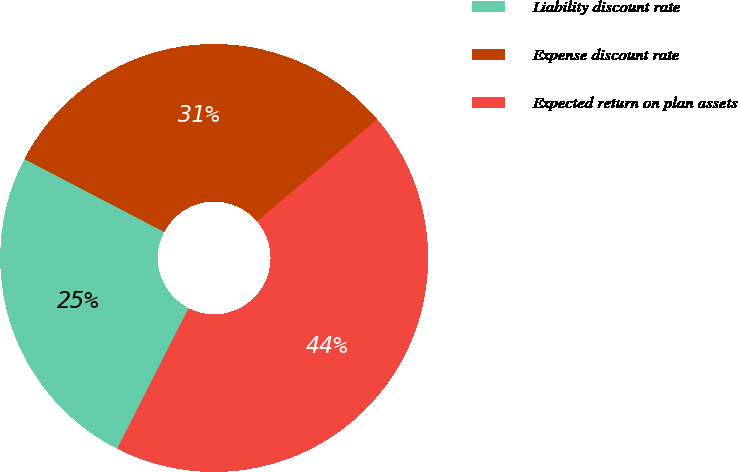<chart> <loc_0><loc_0><loc_500><loc_500><pie_chart><fcel>Liability discount rate<fcel>Expense discount rate<fcel>Expected return on plan assets<nl><fcel>25.17%<fcel>31.13%<fcel>43.71%<nl></chart> 